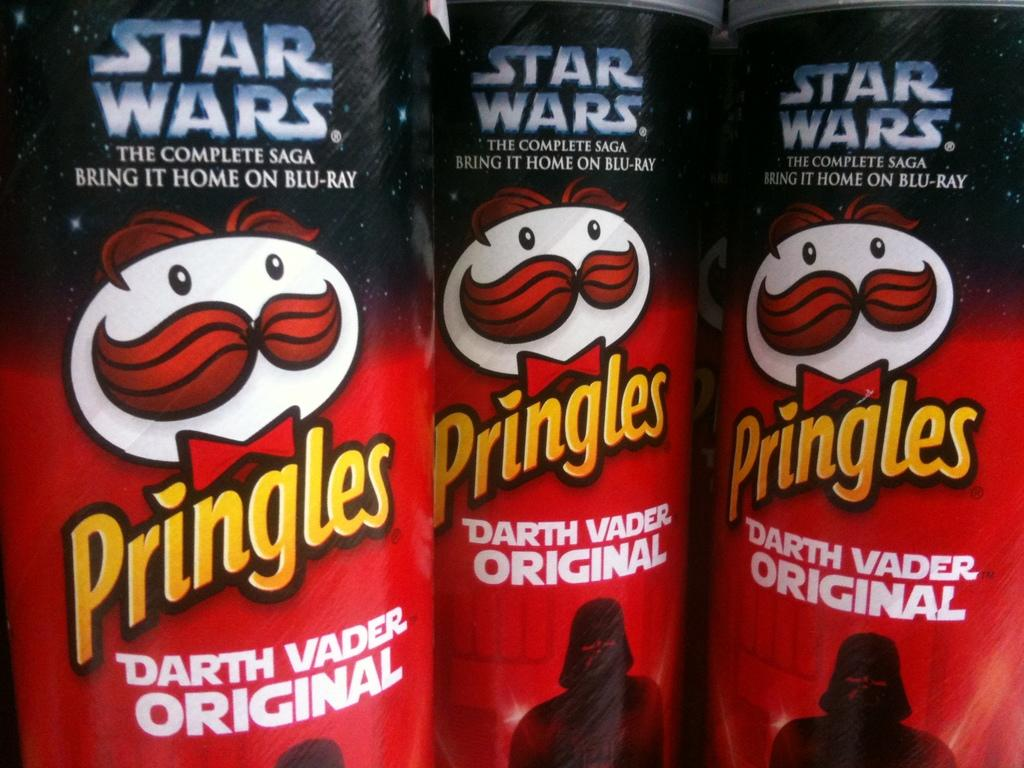Provide a one-sentence caption for the provided image. A close up of three Pringle tubes, each is a star wars special editon Darth Vader Original. 